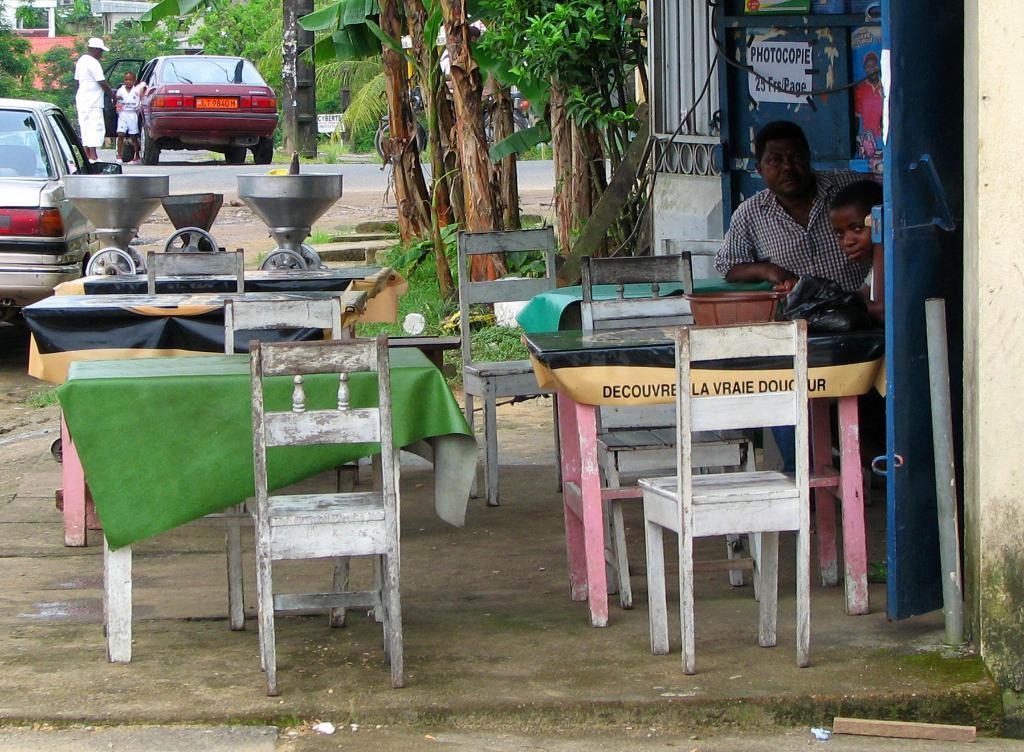In one or two sentences, can you explain what this image depicts? In this image I can see there are few tables, chairs on the ground. I can also see a man is sitting and cars on the road. 